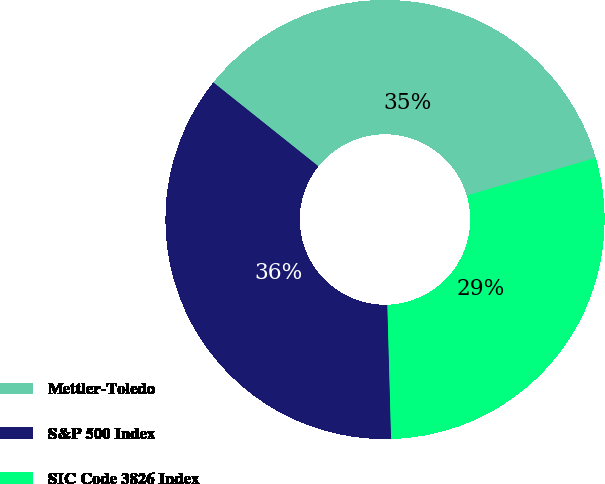Convert chart to OTSL. <chart><loc_0><loc_0><loc_500><loc_500><pie_chart><fcel>Mettler-Toledo<fcel>S&P 500 Index<fcel>SIC Code 3826 Index<nl><fcel>34.75%<fcel>36.17%<fcel>29.08%<nl></chart> 